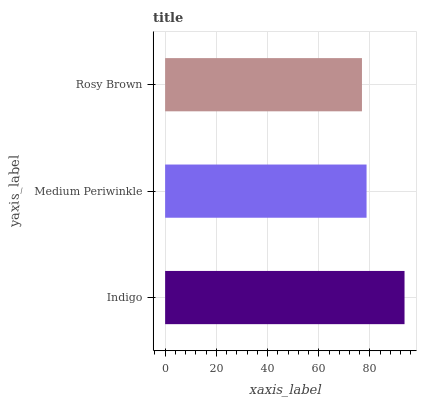Is Rosy Brown the minimum?
Answer yes or no. Yes. Is Indigo the maximum?
Answer yes or no. Yes. Is Medium Periwinkle the minimum?
Answer yes or no. No. Is Medium Periwinkle the maximum?
Answer yes or no. No. Is Indigo greater than Medium Periwinkle?
Answer yes or no. Yes. Is Medium Periwinkle less than Indigo?
Answer yes or no. Yes. Is Medium Periwinkle greater than Indigo?
Answer yes or no. No. Is Indigo less than Medium Periwinkle?
Answer yes or no. No. Is Medium Periwinkle the high median?
Answer yes or no. Yes. Is Medium Periwinkle the low median?
Answer yes or no. Yes. Is Indigo the high median?
Answer yes or no. No. Is Indigo the low median?
Answer yes or no. No. 